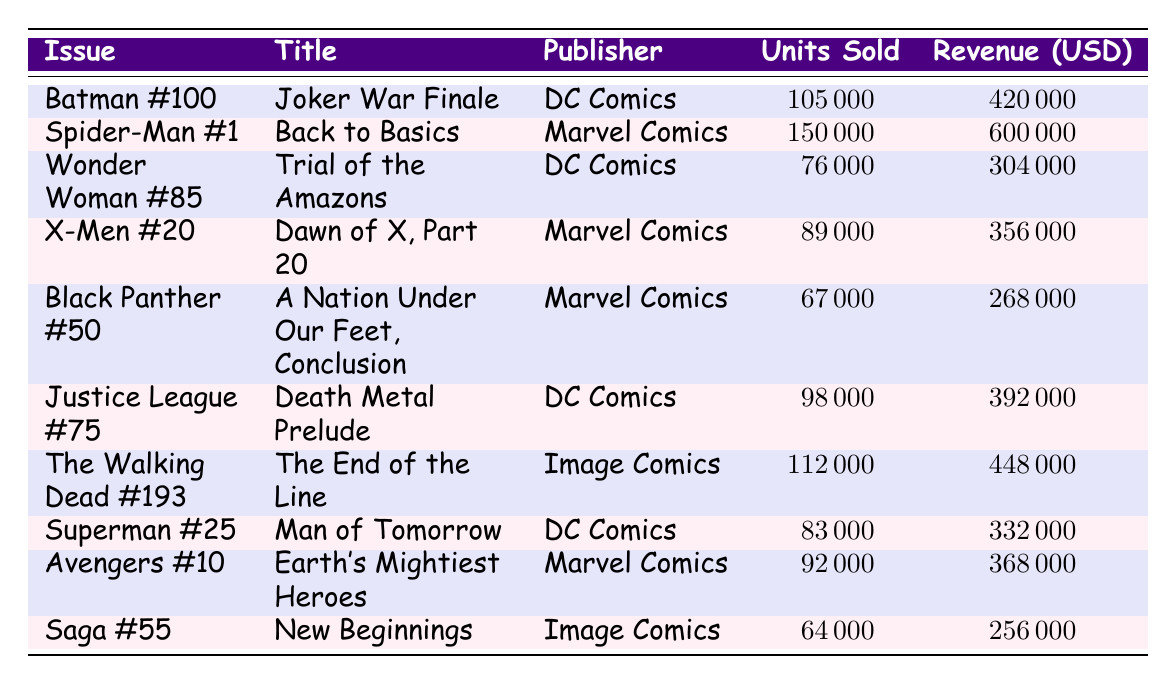What is the title of the comic book "Spider-Man #1"? The table shows the title associated with the comic book issue "Spider-Man #1". Looking at the relevant row, the title is "Back to Basics".
Answer: Back to Basics How many units were sold of "Justice League #75"? Referring to the row for "Justice League #75", it lists the units sold as 98000.
Answer: 98000 Which publisher had the highest revenue from their comic book issues? To determine which publisher had the highest revenue, we can compare the revenue columns for each publisher. The highest revenue listed is for "Spider-Man #1" by Marvel Comics with 600000.
Answer: Marvel Comics What is the total revenue for all DC Comics issues listed? We need to sum the revenue for each DC Comics issue: "Batman #100" (420000), "Wonder Woman #85" (304000), "Justice League #75" (392000), and "Superman #25" (332000). Adding those gives a total of 420000 + 304000 + 392000 + 332000 = 1448000.
Answer: 1448000 Did "The Walking Dead #193" sell more units than "Batman #100"? Comparing sales, "The Walking Dead #193" sold 112000 units while "Batman #100" sold 105000 units. Since 112000 is greater than 105000, the statement is true.
Answer: Yes What is the average revenue for comic book issues published by Image Comics? For Image Comics, the relevant issues are "The Walking Dead #193" (448000) and "Saga #55" (256000). To find the average, sum the revenues (448000 + 256000 = 704000) and divide by the number of issues (2). Thus, 704000 / 2 = 352000.
Answer: 352000 Which comic book title had the lowest revenue? To find the lowest revenue, we compare all the revenue values. The lowest value corresponds to "Saga #55", which has a revenue of 256000.
Answer: Saga #55 How many units were sold for Marvel Comics combined? For Marvel Comics, the issues listed are "Spider-Man #1" (150000), "X-Men #20" (89000), "Black Panther #50" (67000), and "Avengers #10" (92000). Adding these yields a total of 150000 + 89000 + 67000 + 92000 = 398000.
Answer: 398000 